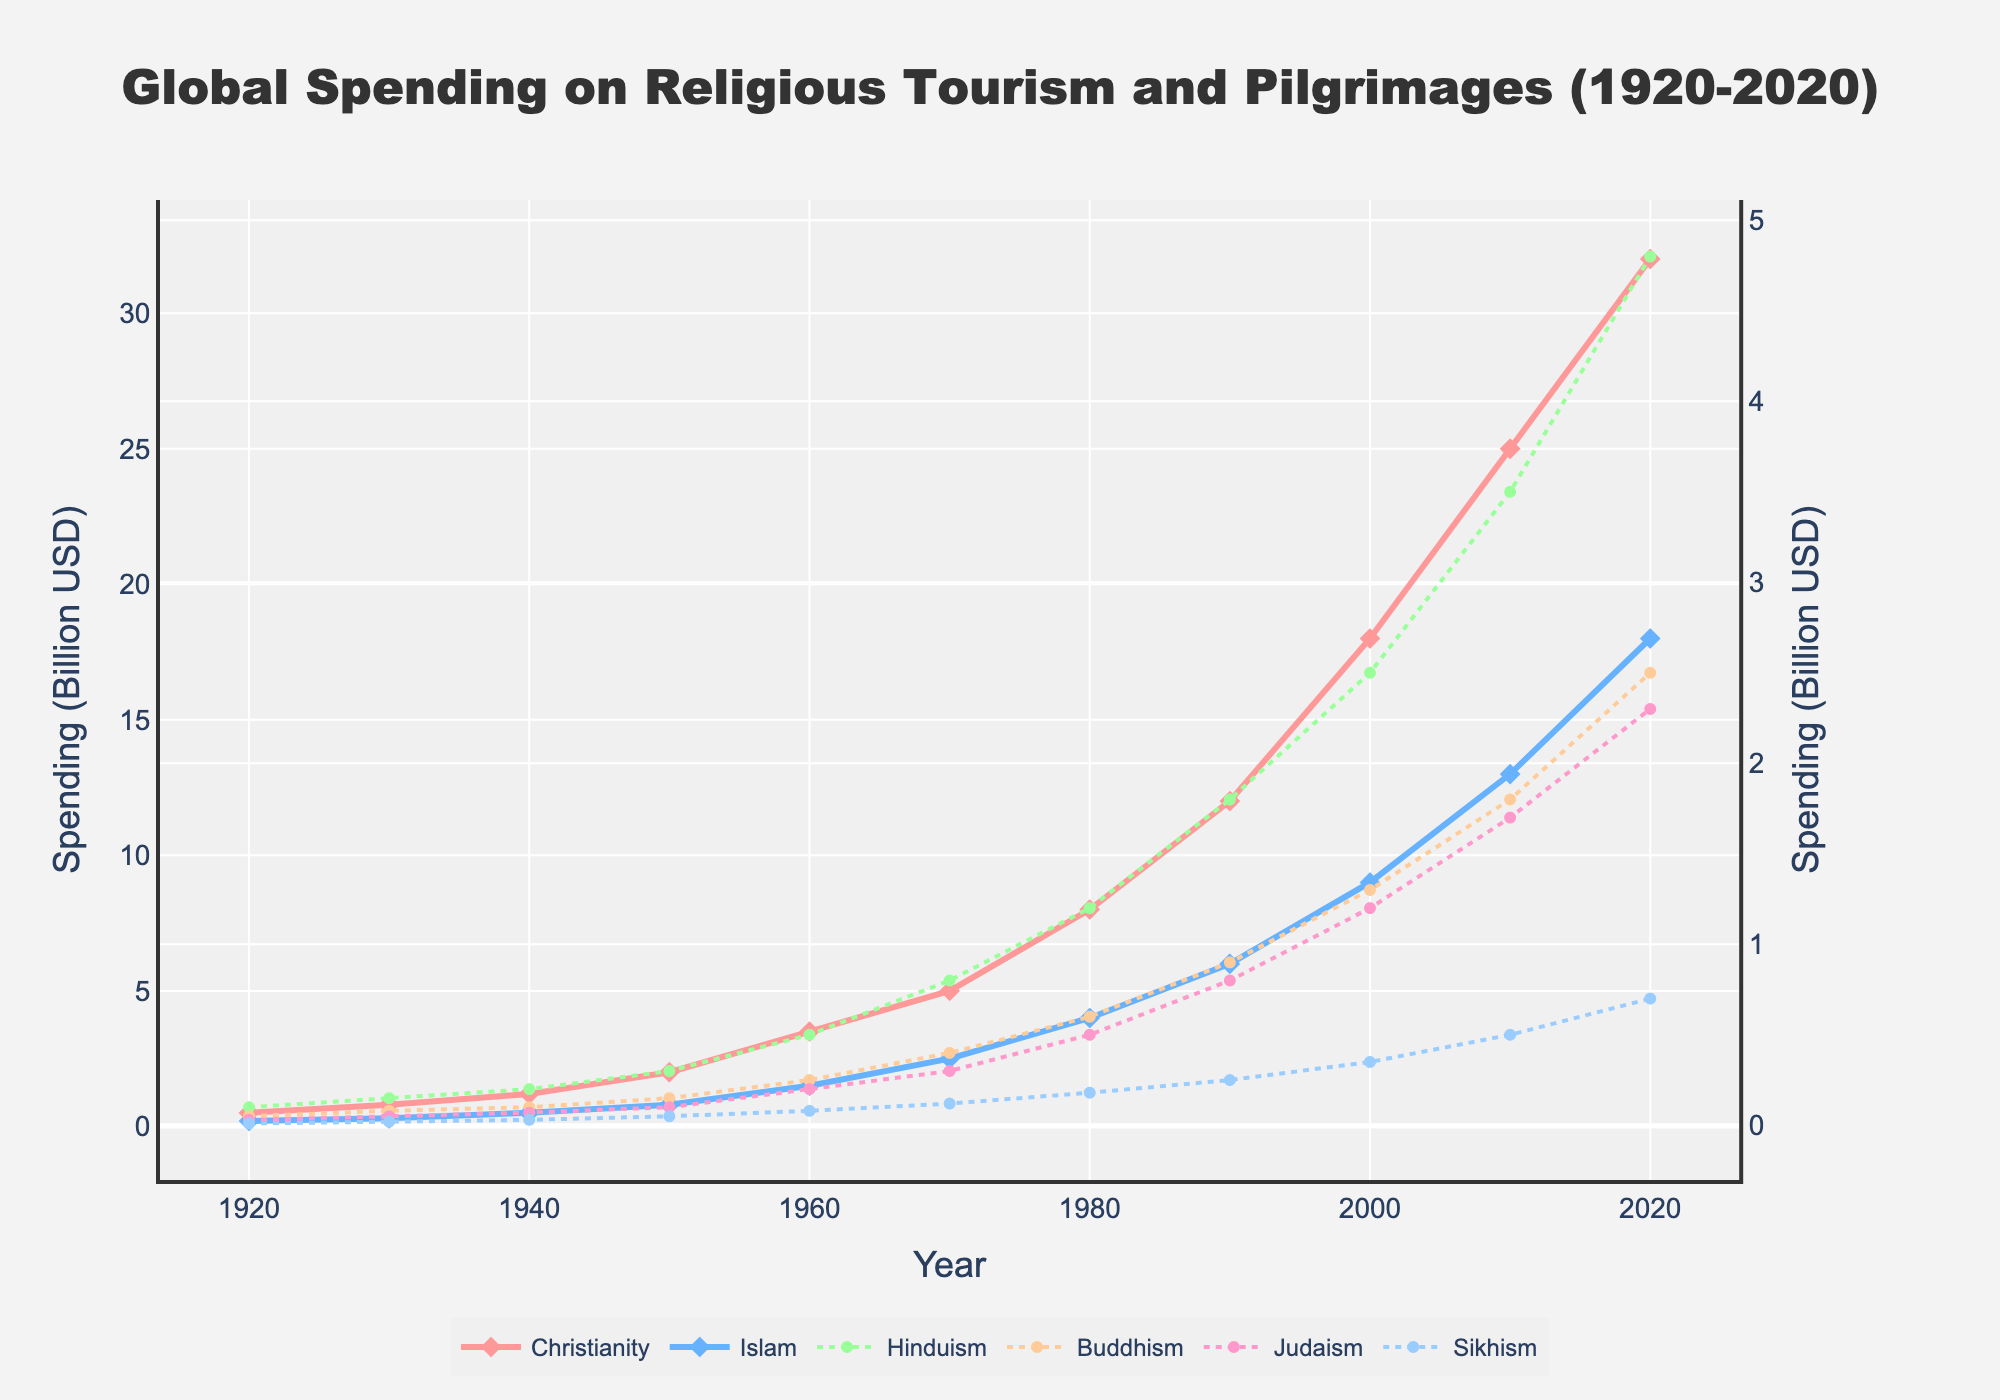What's the trend in global spending on religious tourism and pilgrimages for Christianity over the last century? Observing the line for Christianity, it starts at 0.5 billion USD in 1920 and steadily increases over each decade, reaching 32 billion USD by 2020.
Answer: Increasing Which religion had the greatest increase in spending from 1920 to 2020? To determine this, subtract the 1920 value from the 2020 value for each religion: Christianity (32-0.5=31.5), Islam (18-0.2=17.8), Hinduism (4.8-0.1=4.7), Buddhism (2.5-0.05=2.45), Judaism (2.3-0.03=2.27), Sikhism (0.7-0.01=0.69). Christianity has the greatest increase of 31.5 billion USD.
Answer: Christianity What's the total spending on religious tourism and pilgrimages for all religions combined in 2020? Add the 2020 values for all religions: 32 + 18 + 4.8 + 2.5 + 2.3 + 0.7 = 60.3 billion USD.
Answer: 60.3 billion USD How does the spending trend for Islam compare to Christianity after 1980? After 1980, both religions show increasing trends, but Christianity consistently shows higher spending than Islam, with both seeing steep rises.
Answer: Christianity > Islam What is the difference in spending between Buddhism and Judaism in 2000? Locate the data points for Buddhism (1.3 billion USD) and Judaism (1.2 billion USD) in 2000, and calculate the difference: 1.3 - 1.2 = 0.1 billion USD.
Answer: 0.1 billion USD Which religion shows the slowest growth in spending from 1920 to 2020? Calculate the increase for each religion from 1920 to 2020: Christianity (31.5), Islam (17.8), Hinduism (4.7), Buddhism (2.45), Judaism (2.27), Sikhism (0.69). Sikhism shows the slowest growth of 0.69 billion USD.
Answer: Sikhism Between 1960 and 1980, which religion had the most significant increase in spending? Compute the increase for each religion: Christianity (8-3.5=4.5), Islam (4-1.5=2.5), Hinduism (1.2-0.5=0.7), Buddhism (0.6-0.25=0.35), Judaism (0.5-0.2=0.3), Sikhism (0.18-0.08=0.1). Christianity had the most significant increase of 4.5 billion USD.
Answer: Christianity In which decade did Hinduism's spending see the highest growth rate? Calculate the growth rate for each decade by comparing values: 
1950-1960 (0.5-0.3)/0.3 = 0.67, 
1960-1970 (0.8-0.5)/0.5 = 0.6, 
1970-1980 (1.2-0.8)/0.8 = 0.5, 
1980-1990 (1.8-1.2)/1.2 = 0.5, 
1990-2000 (2.5-1.8)/1.8 = 0.39, 
2000-2010 (3.5-2.5)/2.5 = 0.4, 
2010-2020 (4.8-3.5)/3.5 = 0.37. The highest growth rate occurred between 1950-1960.
Answer: 1950-1960 How has spending on Sikhism changed from 1930 to 2020? Refer to the Sikhism points: 1930 (0.02 billion USD) to 2020 (0.7 billion USD). The change is 0.7 - 0.02 = 0.68 billion USD.
Answer: Increased by 0.68 billion USD 